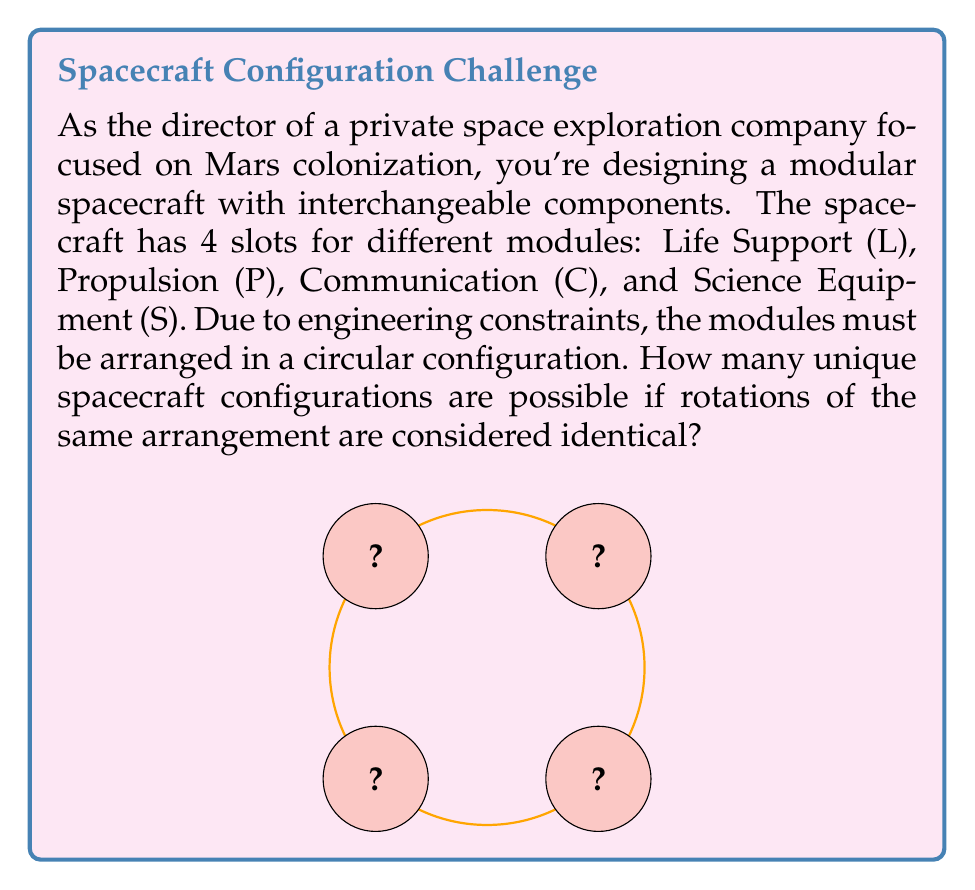Teach me how to tackle this problem. To solve this problem, we can use group theory, specifically the Burnside's lemma (also known as the Orbit-Counting Theorem).

1) First, we identify the group acting on our configurations. In this case, it's the cyclic group $C_4$ of rotations.

2) The total number of colorings (before considering symmetry) is $4! = 24$, as we have 4 distinct modules to arrange.

3) Now, we need to count the number of colorings fixed by each element of $C_4$:
   - Identity rotation (0°): Fixes all 24 colorings
   - 90° rotation: Fixes 0 colorings
   - 180° rotation: Fixes 2 colorings (LPLP, PSPS)
   - 270° rotation: Fixes 0 colorings

4) Applying Burnside's lemma:
   $$ \text{Number of orbits} = \frac{1}{|G|} \sum_{g \in G} |X^g| $$
   where $|G|$ is the order of the group (4 in this case), and $|X^g|$ is the number of colorings fixed by each group element $g$.

5) Substituting our values:
   $$ \text{Number of unique configurations} = \frac{1}{4}(24 + 0 + 2 + 0) = \frac{26}{4} = 6.5 $$

6) Since we can't have a fractional number of configurations, we round down to 6.

Therefore, there are 6 unique spacecraft configurations.
Answer: 6 unique configurations 